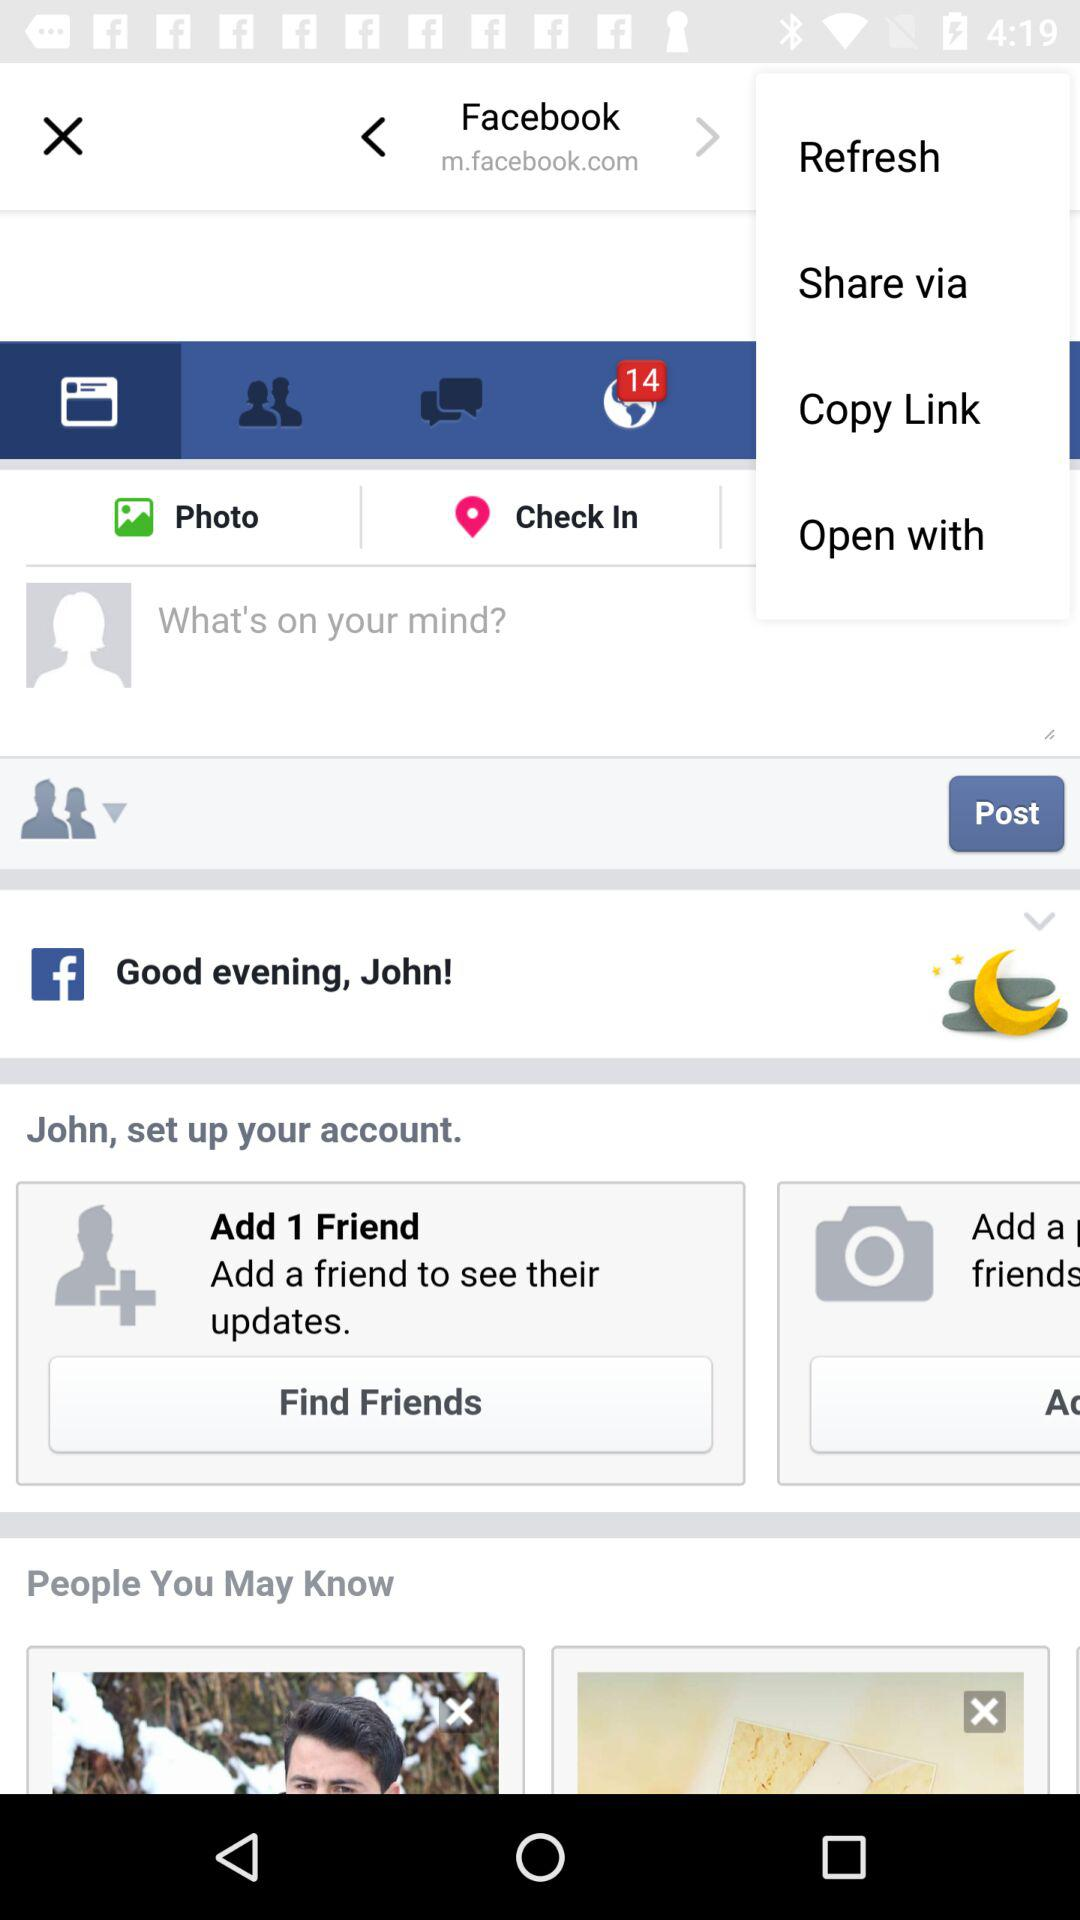How many unread notifications are there? There are 12 unread notifications. 